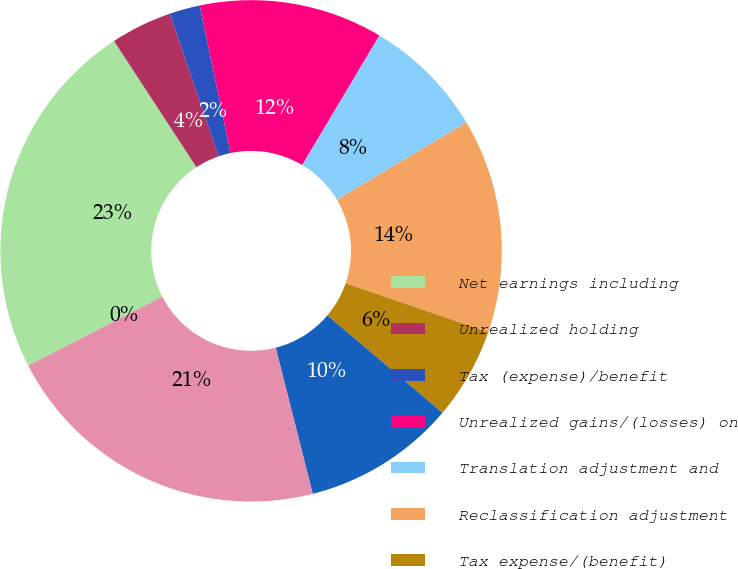Convert chart. <chart><loc_0><loc_0><loc_500><loc_500><pie_chart><fcel>Net earnings including<fcel>Unrealized holding<fcel>Tax (expense)/benefit<fcel>Unrealized gains/(losses) on<fcel>Translation adjustment and<fcel>Reclassification adjustment<fcel>Tax expense/(benefit)<fcel>Other comprehensive<fcel>Comprehensive income including<fcel>Comprehensive income/(loss)<nl><fcel>23.36%<fcel>3.95%<fcel>1.97%<fcel>11.84%<fcel>7.89%<fcel>13.81%<fcel>5.92%<fcel>9.87%<fcel>21.38%<fcel>0.0%<nl></chart> 